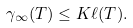<formula> <loc_0><loc_0><loc_500><loc_500>\gamma _ { \infty } ( T ) \leq K \ell ( T ) .</formula> 